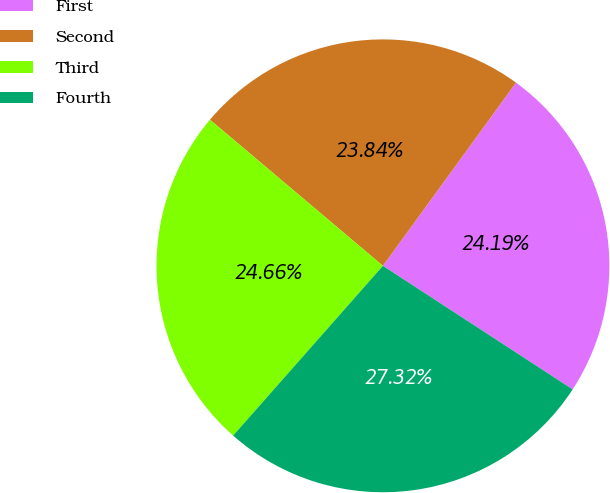Convert chart to OTSL. <chart><loc_0><loc_0><loc_500><loc_500><pie_chart><fcel>First<fcel>Second<fcel>Third<fcel>Fourth<nl><fcel>24.19%<fcel>23.84%<fcel>24.66%<fcel>27.32%<nl></chart> 